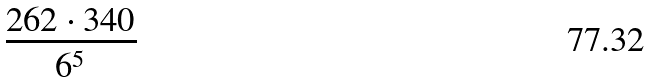<formula> <loc_0><loc_0><loc_500><loc_500>\frac { 2 6 2 \cdot 3 4 0 } { 6 ^ { 5 } }</formula> 